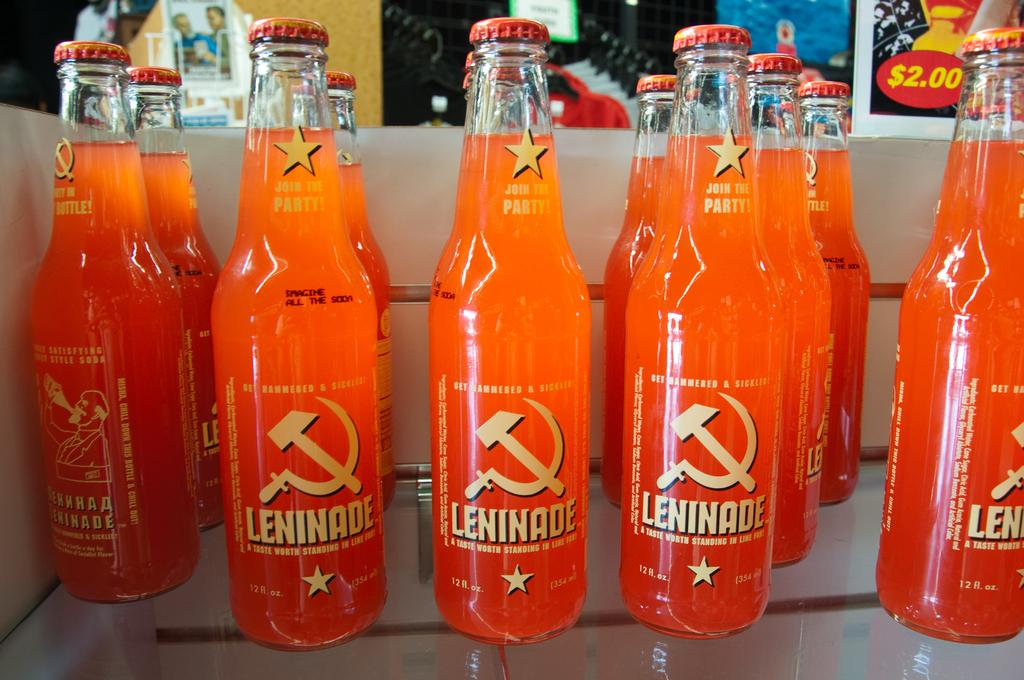<image>
Create a compact narrative representing the image presented. Bottles of orange Leninade are stacked on a glass shelf. 